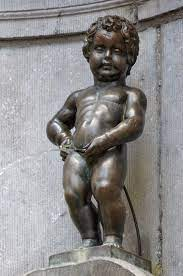What's the cultural significance of the Manneken Pis statue in Brussels? The Manneken Pis is more than just a tourist attraction; it's a symbol of the city's irreverent spirit. Originating from a 17th-century legend, the statue embodies the cheeky attitude of a young Brussels boy. It also serves as a canvas for social and political commentary, with costumes celebrating events, honoring professions, and showcasing cross-cultural friendship. The statue has become an embodiment of local identity and Brussels' sense of humor, as well as its resilience, demonstrated by its numerous restorations after being stolen or vandalized. 